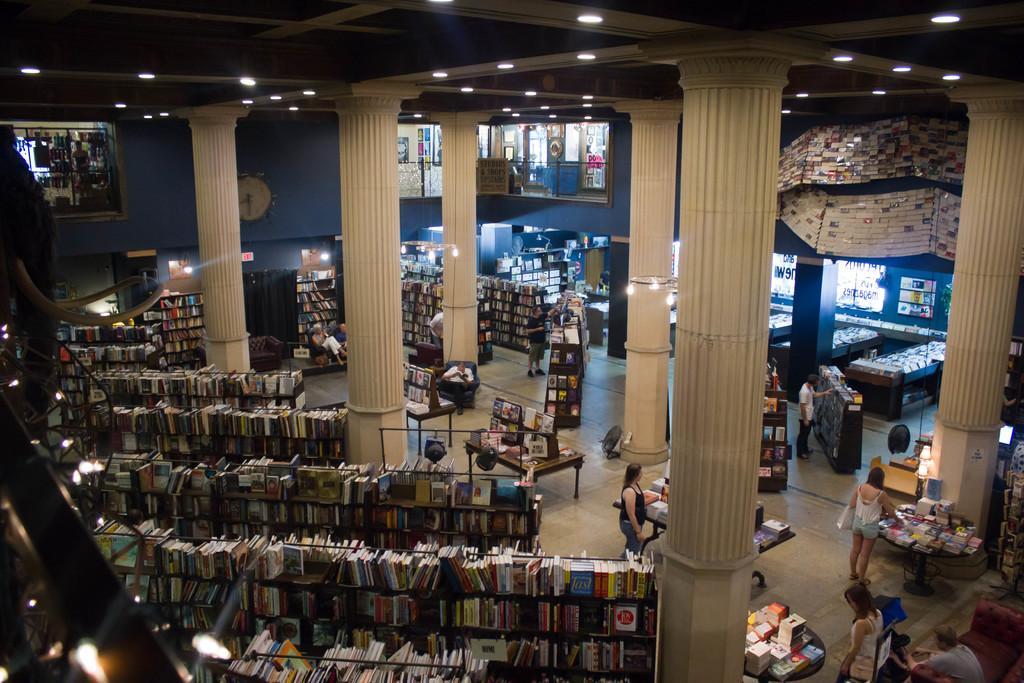How would you summarize this image in a sentence or two? In this picture I can see a number of books on the racks. I can see tables. I can see a few people standing. I can see a few people sitting. I can see the pillars. I can see light arrangements on the roof. I can see the glass fence. I can see the chairs. 